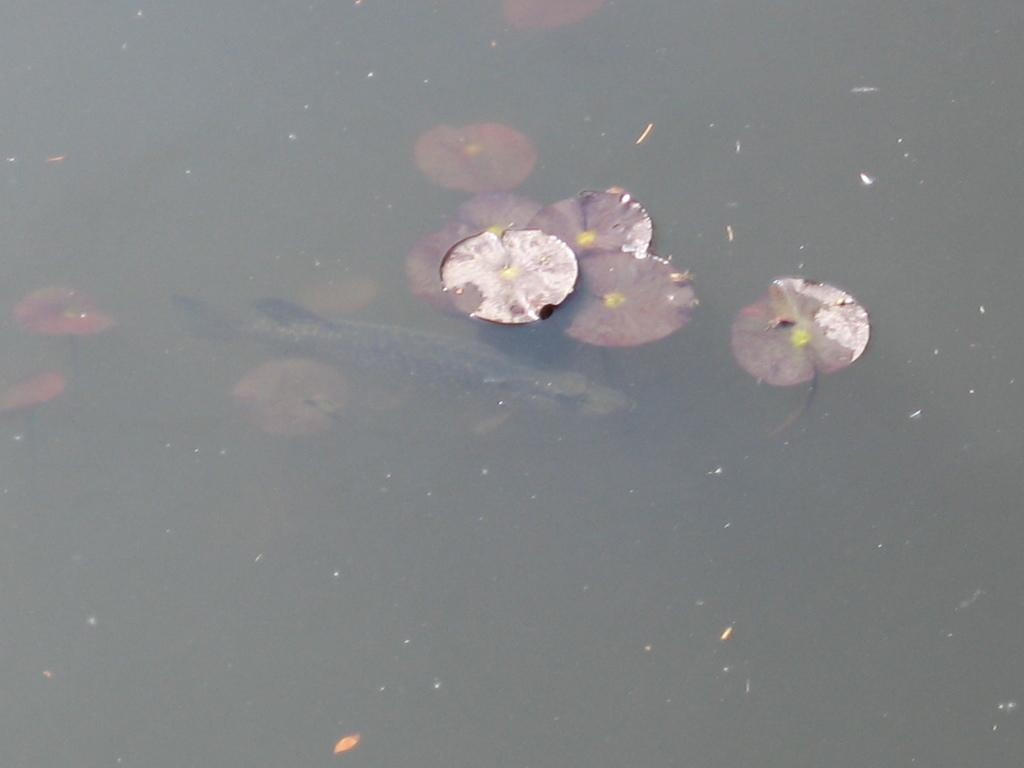What type of animal is in the image? There is a fish in the image. Where is the fish located? The fish is in the water. What else can be seen in the image besides the fish? Leaves are visible in the image. What type of machine can be seen operating in the water in the image? There is no machine present in the image; it features a fish in the water and leaves. How many people are in the crowd visible in the image? There is no crowd present in the image; it features a fish in the water and leaves. 